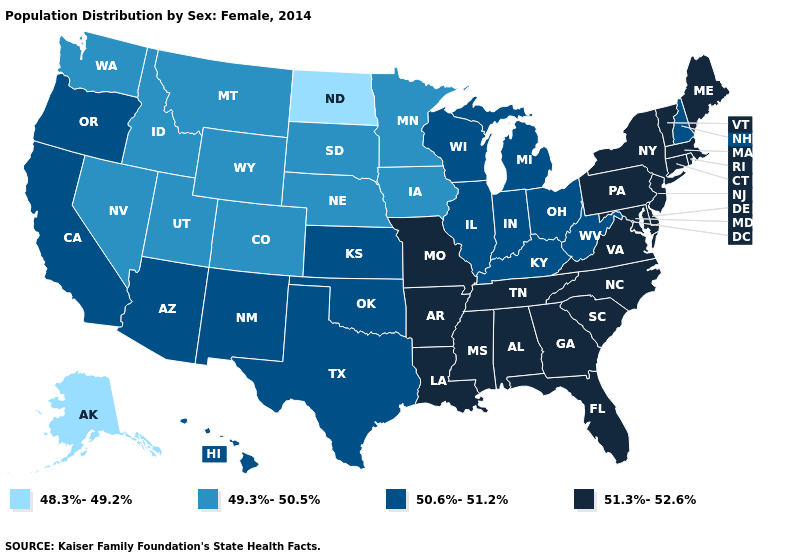Among the states that border West Virginia , which have the highest value?
Quick response, please. Maryland, Pennsylvania, Virginia. Name the states that have a value in the range 49.3%-50.5%?
Quick response, please. Colorado, Idaho, Iowa, Minnesota, Montana, Nebraska, Nevada, South Dakota, Utah, Washington, Wyoming. Does Colorado have the highest value in the USA?
Short answer required. No. Name the states that have a value in the range 51.3%-52.6%?
Short answer required. Alabama, Arkansas, Connecticut, Delaware, Florida, Georgia, Louisiana, Maine, Maryland, Massachusetts, Mississippi, Missouri, New Jersey, New York, North Carolina, Pennsylvania, Rhode Island, South Carolina, Tennessee, Vermont, Virginia. Name the states that have a value in the range 48.3%-49.2%?
Give a very brief answer. Alaska, North Dakota. What is the highest value in the West ?
Quick response, please. 50.6%-51.2%. Name the states that have a value in the range 51.3%-52.6%?
Short answer required. Alabama, Arkansas, Connecticut, Delaware, Florida, Georgia, Louisiana, Maine, Maryland, Massachusetts, Mississippi, Missouri, New Jersey, New York, North Carolina, Pennsylvania, Rhode Island, South Carolina, Tennessee, Vermont, Virginia. What is the value of Oklahoma?
Answer briefly. 50.6%-51.2%. Does Michigan have the same value as New Mexico?
Short answer required. Yes. Name the states that have a value in the range 48.3%-49.2%?
Quick response, please. Alaska, North Dakota. What is the value of Louisiana?
Write a very short answer. 51.3%-52.6%. Name the states that have a value in the range 51.3%-52.6%?
Concise answer only. Alabama, Arkansas, Connecticut, Delaware, Florida, Georgia, Louisiana, Maine, Maryland, Massachusetts, Mississippi, Missouri, New Jersey, New York, North Carolina, Pennsylvania, Rhode Island, South Carolina, Tennessee, Vermont, Virginia. What is the value of Delaware?
Keep it brief. 51.3%-52.6%. Which states have the lowest value in the USA?
Concise answer only. Alaska, North Dakota. 